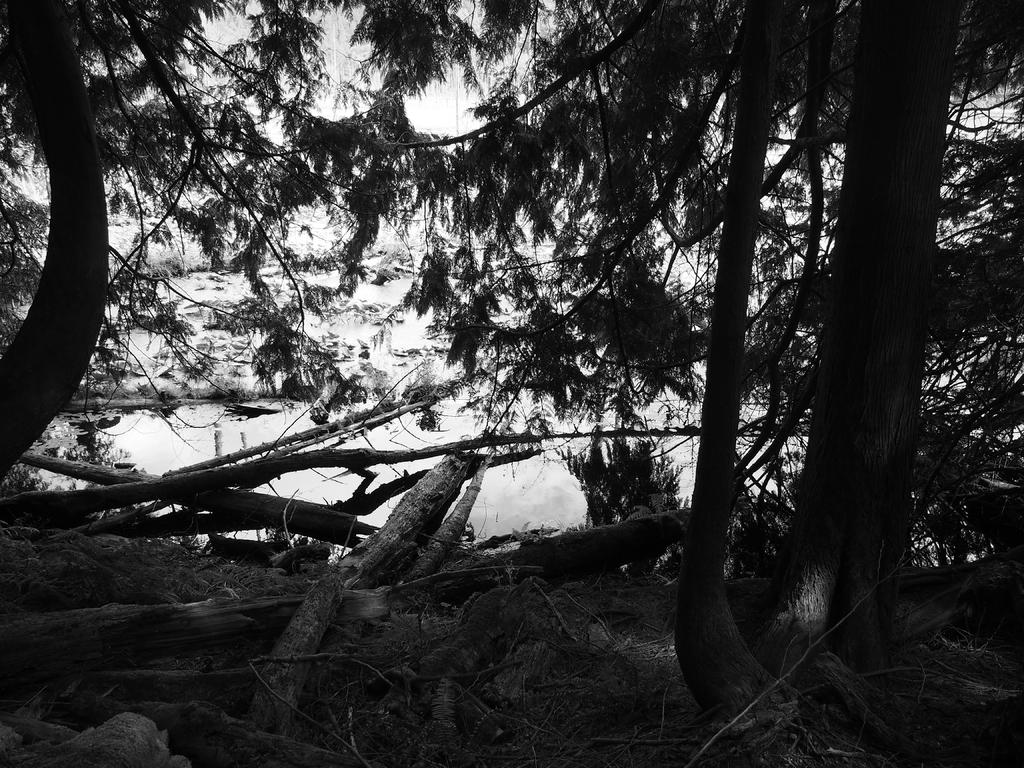What is the color scheme of the image? The image is black and white. What type of vegetation can be seen in the image? There are trees in the image. What objects are located at the bottom of the image? There are logs at the bottom of the image. What can be seen in the background of the image? Water and the sky are visible in the background of the image. What type of square brick structure can be seen in the image? There is no square brick structure present in the image. 